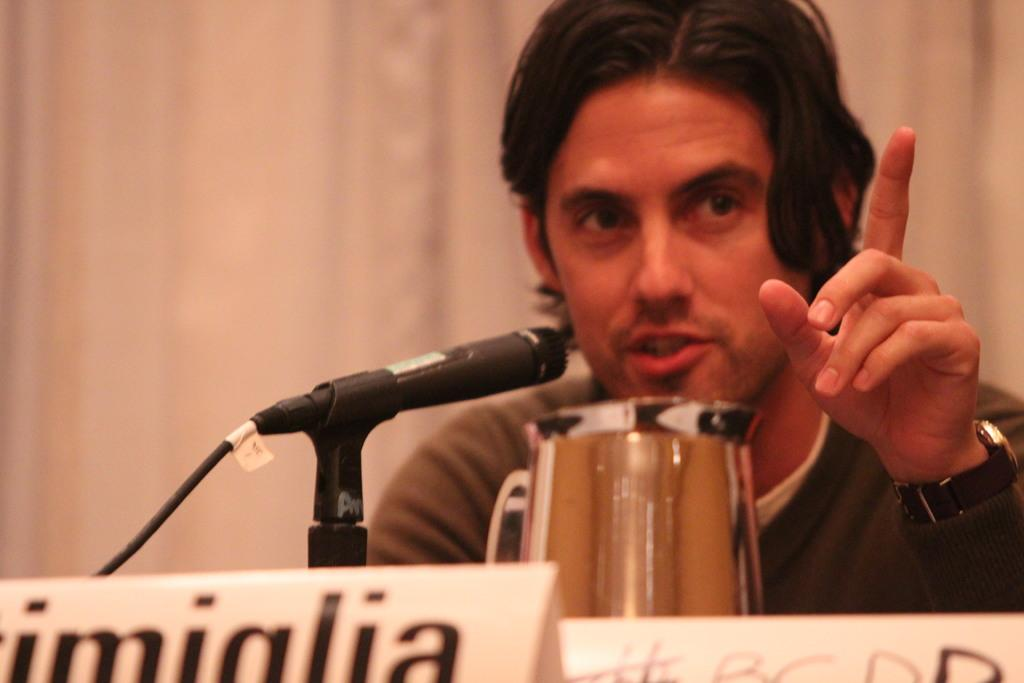What is present in the image? There is a person in the image. What is the person wearing? The person is wearing a watch. What is the person doing? The person is speaking. What objects are in front of the person? There is a mic with a stand, a jug, and boards in front of the person. What type of table is visible in the image? There is no table present in the image. 